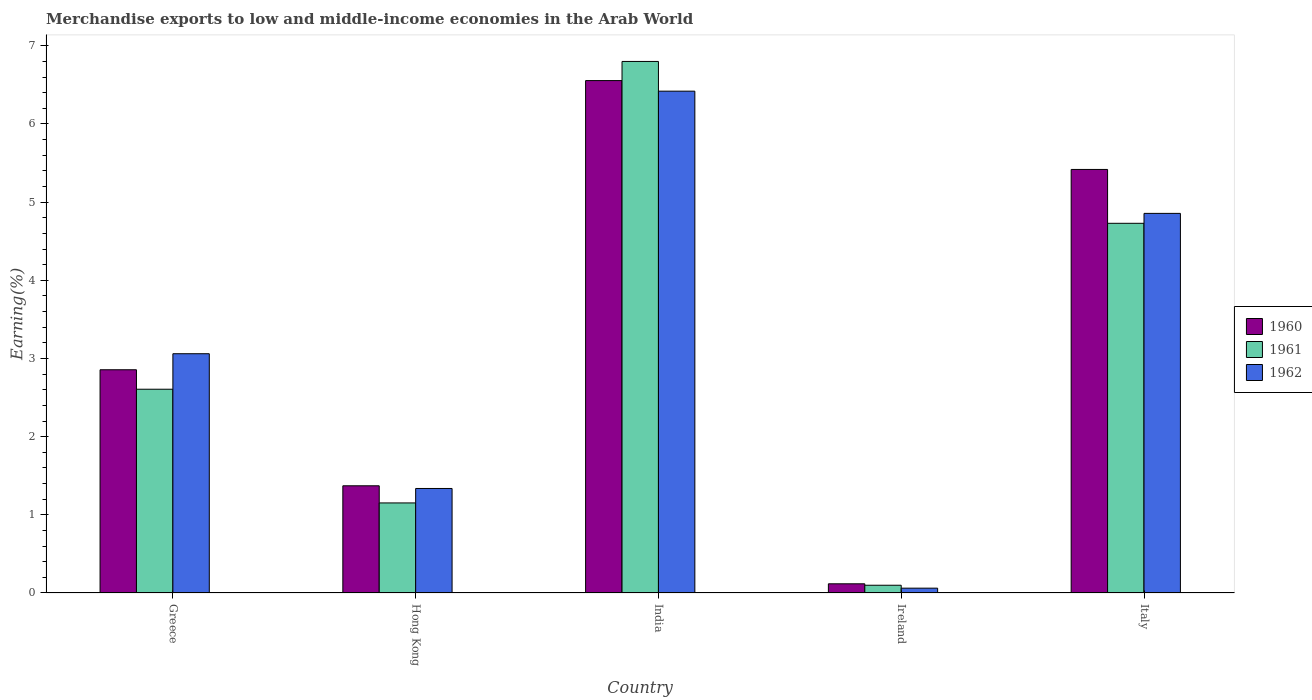How many groups of bars are there?
Your answer should be compact. 5. Are the number of bars on each tick of the X-axis equal?
Offer a very short reply. Yes. What is the label of the 4th group of bars from the left?
Your response must be concise. Ireland. In how many cases, is the number of bars for a given country not equal to the number of legend labels?
Keep it short and to the point. 0. What is the percentage of amount earned from merchandise exports in 1960 in India?
Ensure brevity in your answer.  6.56. Across all countries, what is the maximum percentage of amount earned from merchandise exports in 1962?
Give a very brief answer. 6.42. Across all countries, what is the minimum percentage of amount earned from merchandise exports in 1961?
Offer a terse response. 0.1. In which country was the percentage of amount earned from merchandise exports in 1961 minimum?
Your answer should be very brief. Ireland. What is the total percentage of amount earned from merchandise exports in 1961 in the graph?
Keep it short and to the point. 15.39. What is the difference between the percentage of amount earned from merchandise exports in 1960 in Greece and that in India?
Provide a succinct answer. -3.7. What is the difference between the percentage of amount earned from merchandise exports in 1962 in Ireland and the percentage of amount earned from merchandise exports in 1960 in Italy?
Provide a succinct answer. -5.36. What is the average percentage of amount earned from merchandise exports in 1962 per country?
Offer a terse response. 3.15. What is the difference between the percentage of amount earned from merchandise exports of/in 1960 and percentage of amount earned from merchandise exports of/in 1962 in Hong Kong?
Offer a terse response. 0.03. In how many countries, is the percentage of amount earned from merchandise exports in 1960 greater than 0.8 %?
Your response must be concise. 4. What is the ratio of the percentage of amount earned from merchandise exports in 1960 in India to that in Ireland?
Your answer should be compact. 55.76. What is the difference between the highest and the second highest percentage of amount earned from merchandise exports in 1962?
Make the answer very short. -1.8. What is the difference between the highest and the lowest percentage of amount earned from merchandise exports in 1961?
Offer a very short reply. 6.7. In how many countries, is the percentage of amount earned from merchandise exports in 1960 greater than the average percentage of amount earned from merchandise exports in 1960 taken over all countries?
Offer a terse response. 2. Is the sum of the percentage of amount earned from merchandise exports in 1962 in Hong Kong and India greater than the maximum percentage of amount earned from merchandise exports in 1961 across all countries?
Provide a short and direct response. Yes. What does the 1st bar from the left in Hong Kong represents?
Provide a succinct answer. 1960. Is it the case that in every country, the sum of the percentage of amount earned from merchandise exports in 1961 and percentage of amount earned from merchandise exports in 1962 is greater than the percentage of amount earned from merchandise exports in 1960?
Offer a very short reply. Yes. How many bars are there?
Your response must be concise. 15. Are all the bars in the graph horizontal?
Provide a succinct answer. No. How many countries are there in the graph?
Provide a succinct answer. 5. What is the difference between two consecutive major ticks on the Y-axis?
Provide a short and direct response. 1. Are the values on the major ticks of Y-axis written in scientific E-notation?
Your answer should be compact. No. Where does the legend appear in the graph?
Offer a terse response. Center right. How many legend labels are there?
Your answer should be compact. 3. What is the title of the graph?
Your answer should be compact. Merchandise exports to low and middle-income economies in the Arab World. What is the label or title of the X-axis?
Offer a very short reply. Country. What is the label or title of the Y-axis?
Make the answer very short. Earning(%). What is the Earning(%) in 1960 in Greece?
Provide a short and direct response. 2.86. What is the Earning(%) in 1961 in Greece?
Your answer should be compact. 2.61. What is the Earning(%) of 1962 in Greece?
Ensure brevity in your answer.  3.06. What is the Earning(%) in 1960 in Hong Kong?
Offer a terse response. 1.37. What is the Earning(%) in 1961 in Hong Kong?
Make the answer very short. 1.15. What is the Earning(%) of 1962 in Hong Kong?
Keep it short and to the point. 1.34. What is the Earning(%) of 1960 in India?
Your response must be concise. 6.56. What is the Earning(%) of 1961 in India?
Ensure brevity in your answer.  6.8. What is the Earning(%) of 1962 in India?
Offer a very short reply. 6.42. What is the Earning(%) in 1960 in Ireland?
Keep it short and to the point. 0.12. What is the Earning(%) of 1961 in Ireland?
Your answer should be very brief. 0.1. What is the Earning(%) in 1962 in Ireland?
Make the answer very short. 0.06. What is the Earning(%) of 1960 in Italy?
Give a very brief answer. 5.42. What is the Earning(%) of 1961 in Italy?
Provide a short and direct response. 4.73. What is the Earning(%) of 1962 in Italy?
Offer a terse response. 4.86. Across all countries, what is the maximum Earning(%) in 1960?
Provide a short and direct response. 6.56. Across all countries, what is the maximum Earning(%) in 1961?
Your answer should be compact. 6.8. Across all countries, what is the maximum Earning(%) of 1962?
Provide a short and direct response. 6.42. Across all countries, what is the minimum Earning(%) in 1960?
Provide a short and direct response. 0.12. Across all countries, what is the minimum Earning(%) of 1961?
Offer a terse response. 0.1. Across all countries, what is the minimum Earning(%) of 1962?
Ensure brevity in your answer.  0.06. What is the total Earning(%) of 1960 in the graph?
Your answer should be very brief. 16.32. What is the total Earning(%) of 1961 in the graph?
Your answer should be compact. 15.39. What is the total Earning(%) in 1962 in the graph?
Your answer should be compact. 15.74. What is the difference between the Earning(%) in 1960 in Greece and that in Hong Kong?
Provide a short and direct response. 1.48. What is the difference between the Earning(%) in 1961 in Greece and that in Hong Kong?
Make the answer very short. 1.45. What is the difference between the Earning(%) in 1962 in Greece and that in Hong Kong?
Keep it short and to the point. 1.72. What is the difference between the Earning(%) of 1960 in Greece and that in India?
Keep it short and to the point. -3.7. What is the difference between the Earning(%) in 1961 in Greece and that in India?
Your answer should be very brief. -4.19. What is the difference between the Earning(%) of 1962 in Greece and that in India?
Offer a very short reply. -3.36. What is the difference between the Earning(%) of 1960 in Greece and that in Ireland?
Your answer should be compact. 2.74. What is the difference between the Earning(%) in 1961 in Greece and that in Ireland?
Keep it short and to the point. 2.51. What is the difference between the Earning(%) in 1962 in Greece and that in Ireland?
Give a very brief answer. 3. What is the difference between the Earning(%) in 1960 in Greece and that in Italy?
Give a very brief answer. -2.56. What is the difference between the Earning(%) in 1961 in Greece and that in Italy?
Ensure brevity in your answer.  -2.12. What is the difference between the Earning(%) in 1962 in Greece and that in Italy?
Ensure brevity in your answer.  -1.8. What is the difference between the Earning(%) in 1960 in Hong Kong and that in India?
Make the answer very short. -5.18. What is the difference between the Earning(%) of 1961 in Hong Kong and that in India?
Keep it short and to the point. -5.65. What is the difference between the Earning(%) of 1962 in Hong Kong and that in India?
Give a very brief answer. -5.08. What is the difference between the Earning(%) in 1960 in Hong Kong and that in Ireland?
Ensure brevity in your answer.  1.25. What is the difference between the Earning(%) of 1961 in Hong Kong and that in Ireland?
Provide a succinct answer. 1.05. What is the difference between the Earning(%) in 1962 in Hong Kong and that in Ireland?
Offer a very short reply. 1.28. What is the difference between the Earning(%) in 1960 in Hong Kong and that in Italy?
Give a very brief answer. -4.05. What is the difference between the Earning(%) in 1961 in Hong Kong and that in Italy?
Provide a short and direct response. -3.58. What is the difference between the Earning(%) in 1962 in Hong Kong and that in Italy?
Make the answer very short. -3.52. What is the difference between the Earning(%) of 1960 in India and that in Ireland?
Your answer should be very brief. 6.44. What is the difference between the Earning(%) of 1961 in India and that in Ireland?
Your answer should be compact. 6.7. What is the difference between the Earning(%) in 1962 in India and that in Ireland?
Ensure brevity in your answer.  6.36. What is the difference between the Earning(%) in 1960 in India and that in Italy?
Give a very brief answer. 1.14. What is the difference between the Earning(%) in 1961 in India and that in Italy?
Your answer should be very brief. 2.07. What is the difference between the Earning(%) of 1962 in India and that in Italy?
Your response must be concise. 1.56. What is the difference between the Earning(%) in 1960 in Ireland and that in Italy?
Offer a very short reply. -5.3. What is the difference between the Earning(%) in 1961 in Ireland and that in Italy?
Provide a succinct answer. -4.63. What is the difference between the Earning(%) of 1962 in Ireland and that in Italy?
Provide a short and direct response. -4.79. What is the difference between the Earning(%) in 1960 in Greece and the Earning(%) in 1961 in Hong Kong?
Ensure brevity in your answer.  1.7. What is the difference between the Earning(%) of 1960 in Greece and the Earning(%) of 1962 in Hong Kong?
Provide a short and direct response. 1.52. What is the difference between the Earning(%) of 1961 in Greece and the Earning(%) of 1962 in Hong Kong?
Provide a succinct answer. 1.27. What is the difference between the Earning(%) in 1960 in Greece and the Earning(%) in 1961 in India?
Offer a terse response. -3.94. What is the difference between the Earning(%) of 1960 in Greece and the Earning(%) of 1962 in India?
Offer a terse response. -3.56. What is the difference between the Earning(%) in 1961 in Greece and the Earning(%) in 1962 in India?
Your answer should be very brief. -3.81. What is the difference between the Earning(%) in 1960 in Greece and the Earning(%) in 1961 in Ireland?
Keep it short and to the point. 2.76. What is the difference between the Earning(%) in 1960 in Greece and the Earning(%) in 1962 in Ireland?
Provide a succinct answer. 2.79. What is the difference between the Earning(%) of 1961 in Greece and the Earning(%) of 1962 in Ireland?
Offer a terse response. 2.55. What is the difference between the Earning(%) of 1960 in Greece and the Earning(%) of 1961 in Italy?
Make the answer very short. -1.87. What is the difference between the Earning(%) in 1960 in Greece and the Earning(%) in 1962 in Italy?
Give a very brief answer. -2. What is the difference between the Earning(%) in 1961 in Greece and the Earning(%) in 1962 in Italy?
Give a very brief answer. -2.25. What is the difference between the Earning(%) of 1960 in Hong Kong and the Earning(%) of 1961 in India?
Ensure brevity in your answer.  -5.43. What is the difference between the Earning(%) in 1960 in Hong Kong and the Earning(%) in 1962 in India?
Provide a short and direct response. -5.05. What is the difference between the Earning(%) in 1961 in Hong Kong and the Earning(%) in 1962 in India?
Your response must be concise. -5.27. What is the difference between the Earning(%) of 1960 in Hong Kong and the Earning(%) of 1961 in Ireland?
Your answer should be compact. 1.27. What is the difference between the Earning(%) of 1960 in Hong Kong and the Earning(%) of 1962 in Ireland?
Provide a succinct answer. 1.31. What is the difference between the Earning(%) of 1961 in Hong Kong and the Earning(%) of 1962 in Ireland?
Your answer should be compact. 1.09. What is the difference between the Earning(%) of 1960 in Hong Kong and the Earning(%) of 1961 in Italy?
Ensure brevity in your answer.  -3.36. What is the difference between the Earning(%) of 1960 in Hong Kong and the Earning(%) of 1962 in Italy?
Offer a very short reply. -3.48. What is the difference between the Earning(%) of 1961 in Hong Kong and the Earning(%) of 1962 in Italy?
Your answer should be very brief. -3.7. What is the difference between the Earning(%) in 1960 in India and the Earning(%) in 1961 in Ireland?
Your answer should be compact. 6.46. What is the difference between the Earning(%) in 1960 in India and the Earning(%) in 1962 in Ireland?
Your answer should be compact. 6.49. What is the difference between the Earning(%) of 1961 in India and the Earning(%) of 1962 in Ireland?
Give a very brief answer. 6.74. What is the difference between the Earning(%) of 1960 in India and the Earning(%) of 1961 in Italy?
Make the answer very short. 1.83. What is the difference between the Earning(%) in 1960 in India and the Earning(%) in 1962 in Italy?
Keep it short and to the point. 1.7. What is the difference between the Earning(%) of 1961 in India and the Earning(%) of 1962 in Italy?
Give a very brief answer. 1.94. What is the difference between the Earning(%) in 1960 in Ireland and the Earning(%) in 1961 in Italy?
Offer a terse response. -4.61. What is the difference between the Earning(%) in 1960 in Ireland and the Earning(%) in 1962 in Italy?
Your answer should be very brief. -4.74. What is the difference between the Earning(%) in 1961 in Ireland and the Earning(%) in 1962 in Italy?
Make the answer very short. -4.76. What is the average Earning(%) in 1960 per country?
Ensure brevity in your answer.  3.26. What is the average Earning(%) of 1961 per country?
Ensure brevity in your answer.  3.08. What is the average Earning(%) in 1962 per country?
Your response must be concise. 3.15. What is the difference between the Earning(%) in 1960 and Earning(%) in 1961 in Greece?
Give a very brief answer. 0.25. What is the difference between the Earning(%) in 1960 and Earning(%) in 1962 in Greece?
Keep it short and to the point. -0.21. What is the difference between the Earning(%) of 1961 and Earning(%) of 1962 in Greece?
Your answer should be very brief. -0.45. What is the difference between the Earning(%) of 1960 and Earning(%) of 1961 in Hong Kong?
Your answer should be very brief. 0.22. What is the difference between the Earning(%) in 1960 and Earning(%) in 1962 in Hong Kong?
Make the answer very short. 0.03. What is the difference between the Earning(%) in 1961 and Earning(%) in 1962 in Hong Kong?
Offer a terse response. -0.18. What is the difference between the Earning(%) of 1960 and Earning(%) of 1961 in India?
Make the answer very short. -0.24. What is the difference between the Earning(%) in 1960 and Earning(%) in 1962 in India?
Your answer should be compact. 0.14. What is the difference between the Earning(%) of 1961 and Earning(%) of 1962 in India?
Offer a terse response. 0.38. What is the difference between the Earning(%) of 1960 and Earning(%) of 1961 in Ireland?
Your answer should be compact. 0.02. What is the difference between the Earning(%) in 1960 and Earning(%) in 1962 in Ireland?
Make the answer very short. 0.06. What is the difference between the Earning(%) in 1961 and Earning(%) in 1962 in Ireland?
Provide a short and direct response. 0.04. What is the difference between the Earning(%) in 1960 and Earning(%) in 1961 in Italy?
Your answer should be very brief. 0.69. What is the difference between the Earning(%) of 1960 and Earning(%) of 1962 in Italy?
Make the answer very short. 0.56. What is the difference between the Earning(%) in 1961 and Earning(%) in 1962 in Italy?
Give a very brief answer. -0.13. What is the ratio of the Earning(%) in 1960 in Greece to that in Hong Kong?
Your answer should be very brief. 2.08. What is the ratio of the Earning(%) in 1961 in Greece to that in Hong Kong?
Offer a terse response. 2.26. What is the ratio of the Earning(%) in 1962 in Greece to that in Hong Kong?
Your answer should be compact. 2.29. What is the ratio of the Earning(%) of 1960 in Greece to that in India?
Provide a short and direct response. 0.44. What is the ratio of the Earning(%) in 1961 in Greece to that in India?
Offer a terse response. 0.38. What is the ratio of the Earning(%) of 1962 in Greece to that in India?
Make the answer very short. 0.48. What is the ratio of the Earning(%) of 1960 in Greece to that in Ireland?
Offer a terse response. 24.29. What is the ratio of the Earning(%) of 1961 in Greece to that in Ireland?
Offer a very short reply. 26.29. What is the ratio of the Earning(%) of 1962 in Greece to that in Ireland?
Your answer should be very brief. 49.65. What is the ratio of the Earning(%) of 1960 in Greece to that in Italy?
Make the answer very short. 0.53. What is the ratio of the Earning(%) of 1961 in Greece to that in Italy?
Provide a short and direct response. 0.55. What is the ratio of the Earning(%) of 1962 in Greece to that in Italy?
Provide a succinct answer. 0.63. What is the ratio of the Earning(%) in 1960 in Hong Kong to that in India?
Your response must be concise. 0.21. What is the ratio of the Earning(%) in 1961 in Hong Kong to that in India?
Provide a succinct answer. 0.17. What is the ratio of the Earning(%) in 1962 in Hong Kong to that in India?
Give a very brief answer. 0.21. What is the ratio of the Earning(%) in 1960 in Hong Kong to that in Ireland?
Keep it short and to the point. 11.66. What is the ratio of the Earning(%) in 1961 in Hong Kong to that in Ireland?
Your answer should be compact. 11.62. What is the ratio of the Earning(%) of 1962 in Hong Kong to that in Ireland?
Offer a terse response. 21.69. What is the ratio of the Earning(%) of 1960 in Hong Kong to that in Italy?
Your answer should be very brief. 0.25. What is the ratio of the Earning(%) in 1961 in Hong Kong to that in Italy?
Provide a succinct answer. 0.24. What is the ratio of the Earning(%) of 1962 in Hong Kong to that in Italy?
Provide a succinct answer. 0.28. What is the ratio of the Earning(%) of 1960 in India to that in Ireland?
Your response must be concise. 55.76. What is the ratio of the Earning(%) of 1961 in India to that in Ireland?
Provide a short and direct response. 68.57. What is the ratio of the Earning(%) in 1962 in India to that in Ireland?
Make the answer very short. 104.13. What is the ratio of the Earning(%) of 1960 in India to that in Italy?
Give a very brief answer. 1.21. What is the ratio of the Earning(%) of 1961 in India to that in Italy?
Offer a terse response. 1.44. What is the ratio of the Earning(%) of 1962 in India to that in Italy?
Give a very brief answer. 1.32. What is the ratio of the Earning(%) of 1960 in Ireland to that in Italy?
Your answer should be very brief. 0.02. What is the ratio of the Earning(%) of 1961 in Ireland to that in Italy?
Keep it short and to the point. 0.02. What is the ratio of the Earning(%) of 1962 in Ireland to that in Italy?
Offer a terse response. 0.01. What is the difference between the highest and the second highest Earning(%) of 1960?
Your answer should be compact. 1.14. What is the difference between the highest and the second highest Earning(%) in 1961?
Provide a short and direct response. 2.07. What is the difference between the highest and the second highest Earning(%) in 1962?
Your response must be concise. 1.56. What is the difference between the highest and the lowest Earning(%) of 1960?
Keep it short and to the point. 6.44. What is the difference between the highest and the lowest Earning(%) of 1961?
Give a very brief answer. 6.7. What is the difference between the highest and the lowest Earning(%) in 1962?
Ensure brevity in your answer.  6.36. 